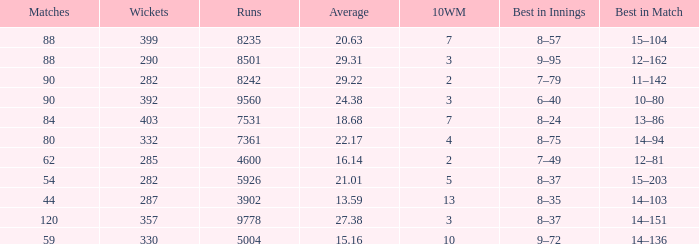Could you parse the entire table? {'header': ['Matches', 'Wickets', 'Runs', 'Average', '10WM', 'Best in Innings', 'Best in Match'], 'rows': [['88', '399', '8235', '20.63', '7', '8–57', '15–104'], ['88', '290', '8501', '29.31', '3', '9–95', '12–162'], ['90', '282', '8242', '29.22', '2', '7–79', '11–142'], ['90', '392', '9560', '24.38', '3', '6–40', '10–80'], ['84', '403', '7531', '18.68', '7', '8–24', '13–86'], ['80', '332', '7361', '22.17', '4', '8–75', '14–94'], ['62', '285', '4600', '16.14', '2', '7–49', '12–81'], ['54', '282', '5926', '21.01', '5', '8–37', '15–203'], ['44', '287', '3902', '13.59', '13', '8–35', '14–103'], ['120', '357', '9778', '27.38', '3', '8–37', '14–151'], ['59', '330', '5004', '15.16', '10', '9–72', '14–136']]} How many wickets have runs under 7531, matches over 44, and an average of 22.17? 332.0. 